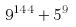Convert formula to latex. <formula><loc_0><loc_0><loc_500><loc_500>9 ^ { 1 4 4 } + 5 ^ { 9 }</formula> 